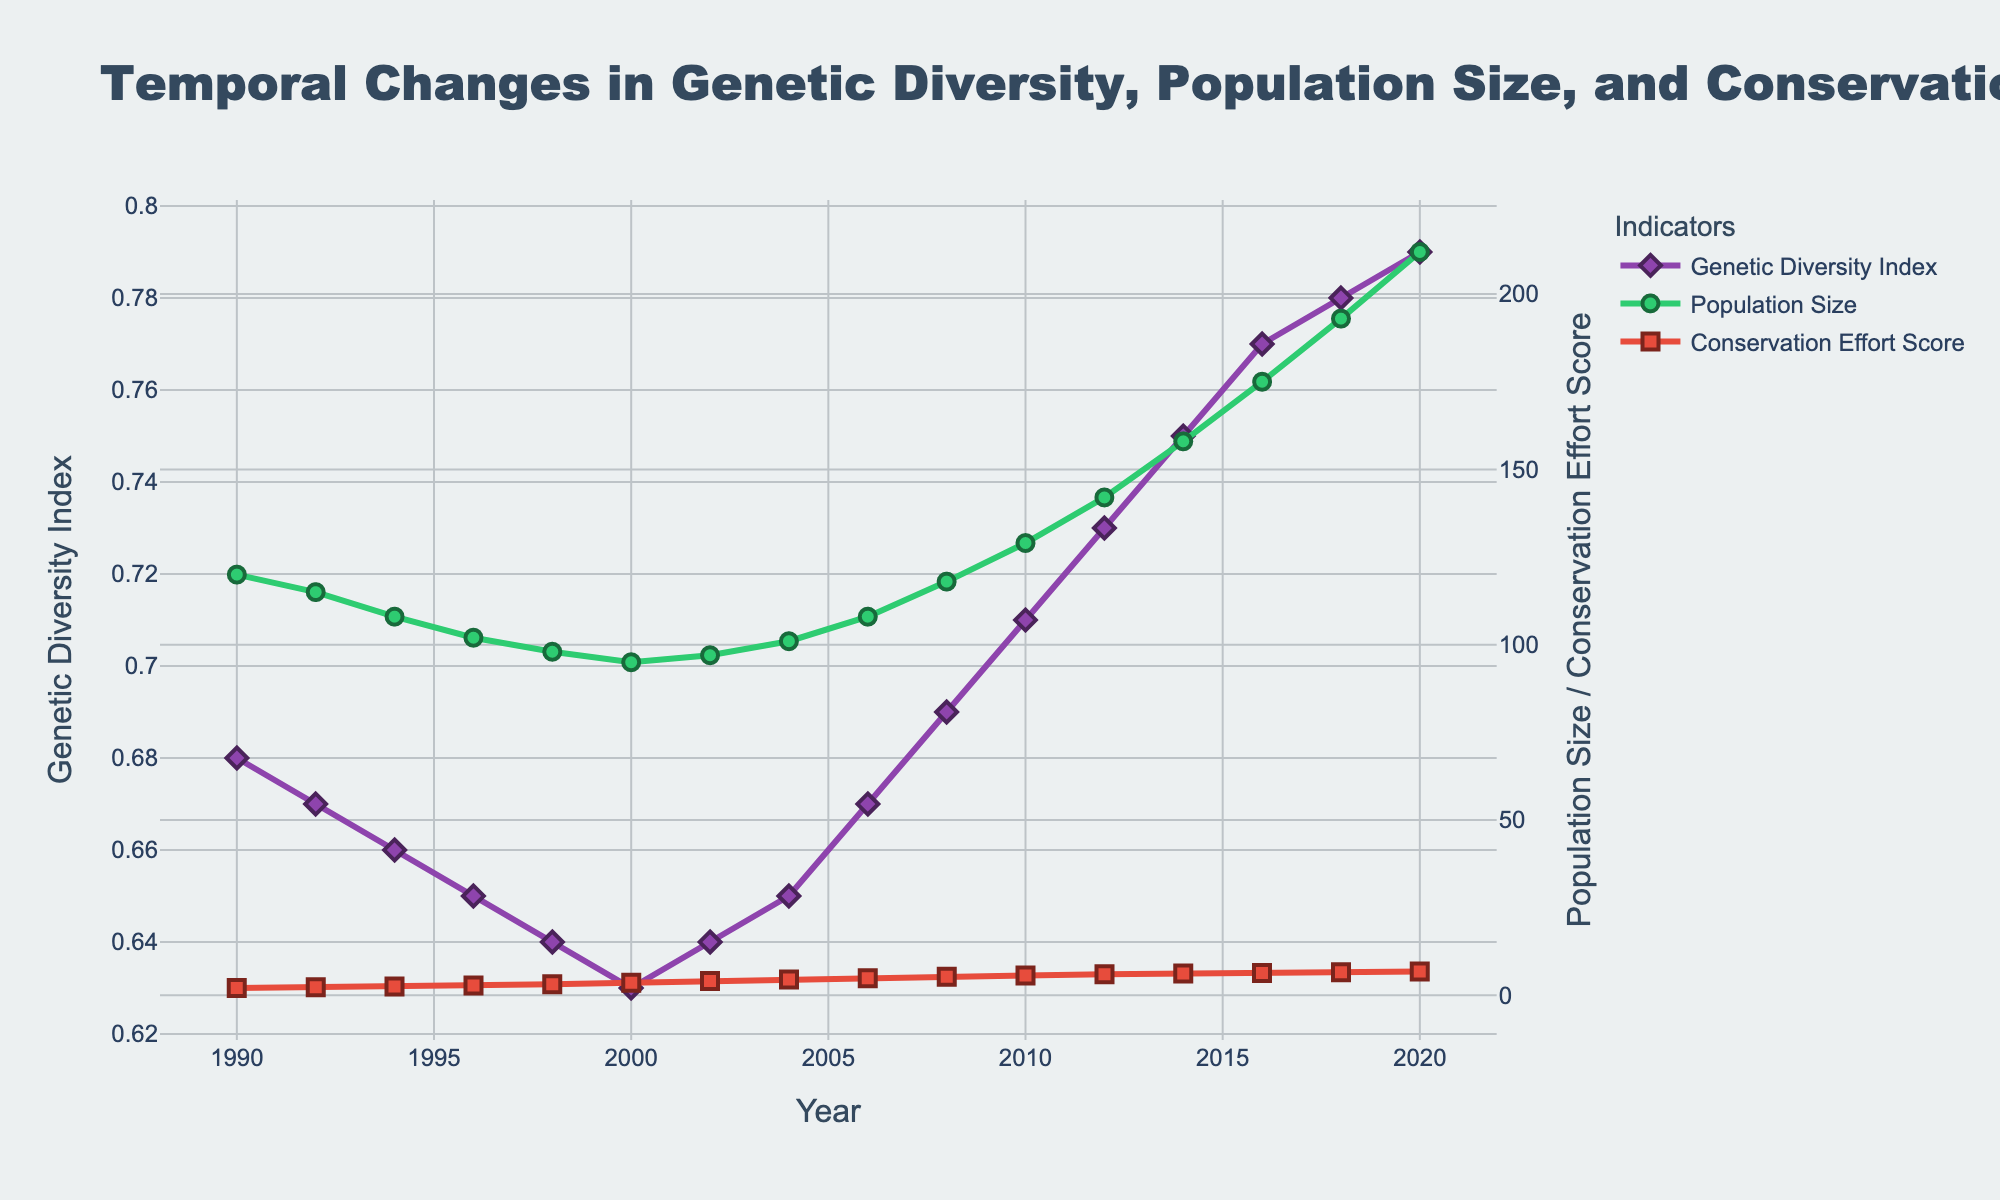What is the trend in the Genetic Diversity Index from 1990 to 2020? The Genetic Diversity Index decreases from 1990 to 2000 and then starts to increase from 2002 to 2020, signifying a U-shaped trend.
Answer: U-shaped Which year recorded the highest Population Size? From the figure, the Population Size peaks in the year 2020.
Answer: 2020 Between 2002 and 2012, how did the Conservation Effort Score change? The Conservation Effort Score increases consistently from 4.1 in 2002 to 6.0 in 2012.
Answer: Increased Compare the Genetic Diversity Index in 1990 and 2020. Which one is higher? In 1990, the Genetic Diversity Index is 0.68, while in 2020, it is 0.79. Hence, it is higher in 2020.
Answer: 2020 What is the difference in Population Size between the years 2014 and 1998? The Population Size in 2014 is 158, and in 1998, it is 98. The difference is 158 - 98 = 60.
Answer: 60 Describe the visual difference in the markers used for Population Size and Conservation Effort Scores. The markers for Population Size are circles, while those for Conservation Effort Scores are squares. Both have distinguishing colors and outlines.
Answer: Circles vs. Squares What is the average Conservation Effort Score from 1996 to 2000? The Conservation Effort Scores from 1996 to 2000 are 2.8, 3.2, and 3.6. The average is (2.8 + 3.2 + 3.6) / 3 = 3.2.
Answer: 3.2 Did genetic diversity ever drop below 0.63? If so, in which year did this occur? The Genetic Diversity Index never falls below 0.63 at any point in the plotted period.
Answer: No, never Compare the rate of increase in Population Size between 2000 and 2004 with the rate of increase between 2016 and 2020. Which period experienced a higher growth rate? From 2000 to 2004, Population Size increased from 95 to 101, a difference of 6 in four years. From 2016 to 2020, it increased from 175 to 212, a difference of 37 in four years. Thus, the latter period had a higher growth rate.
Answer: 2016-2020 Is there a consistent relationship between Conservation Effort Score and Genetic Diversity Index? Initially, as the Conservation Effort Score increases, the Genetic Diversity Index decreases until 2000. Afterward, both begin to increase, suggesting an eventual positive relationship from 2000 onwards.
Answer: Shifting relationship 